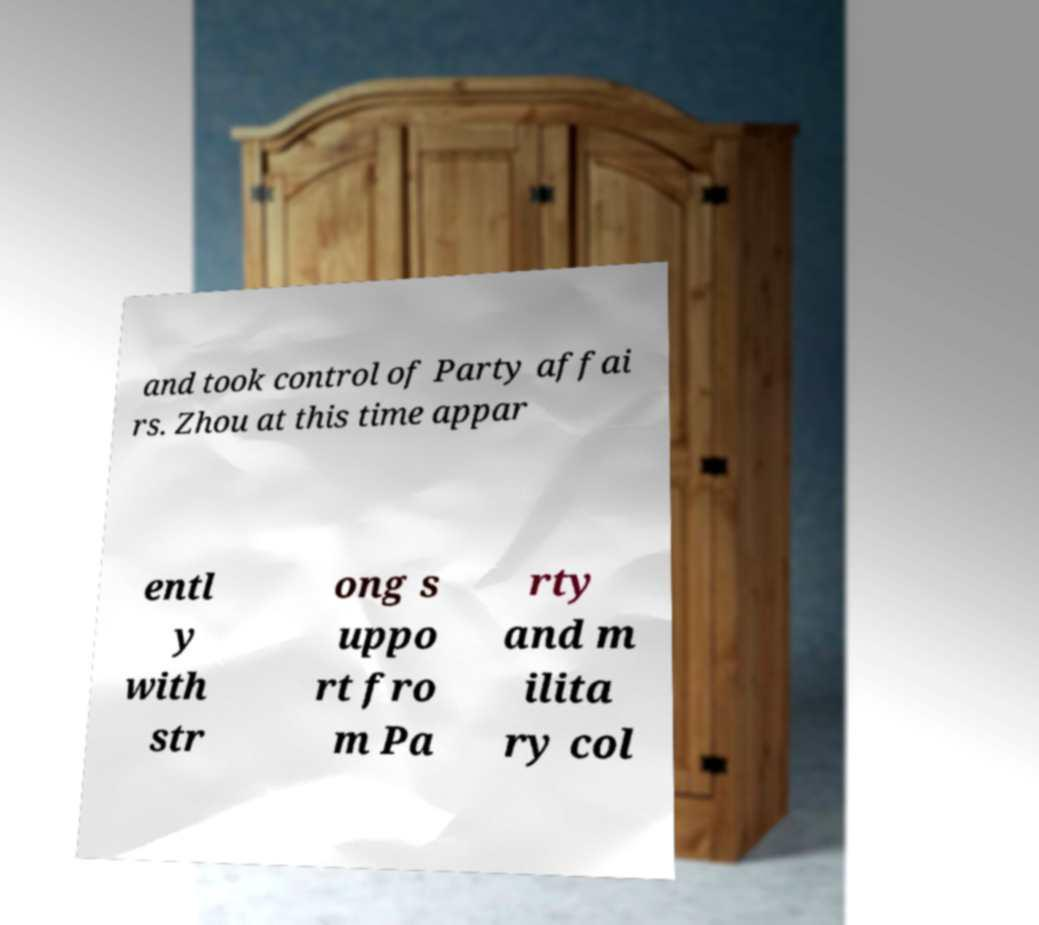I need the written content from this picture converted into text. Can you do that? and took control of Party affai rs. Zhou at this time appar entl y with str ong s uppo rt fro m Pa rty and m ilita ry col 